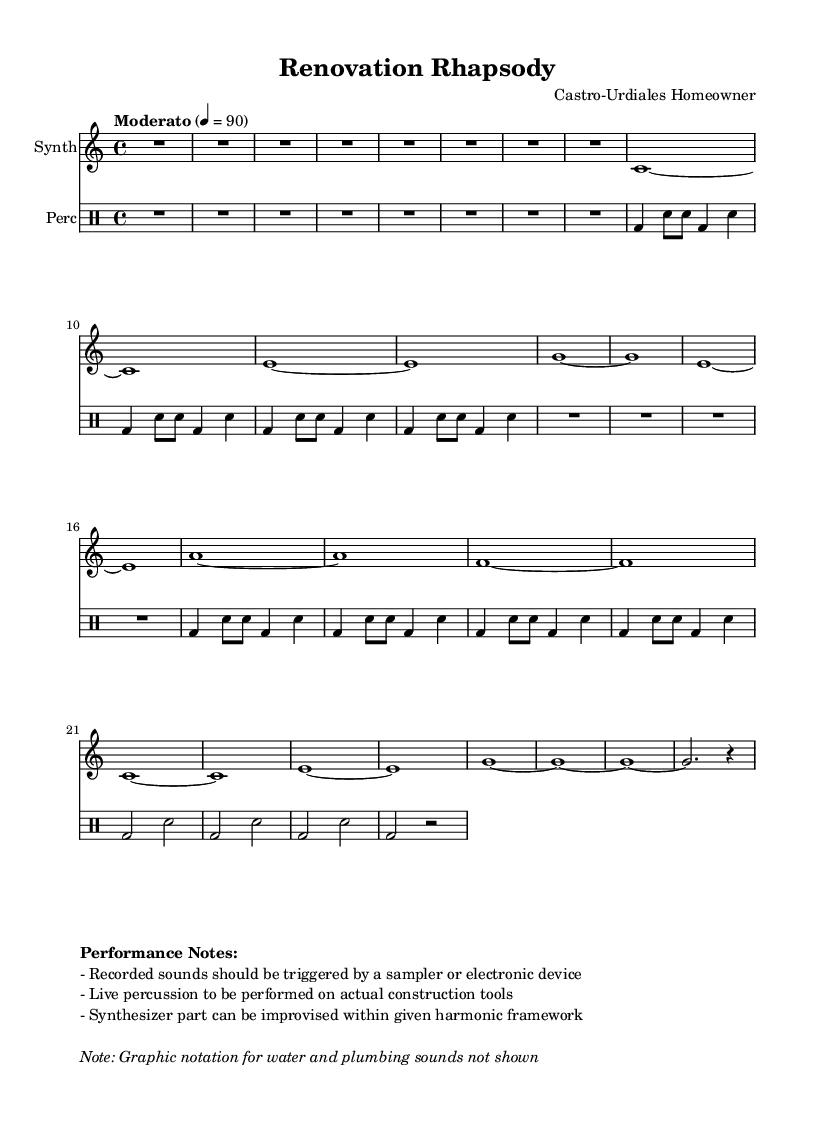What is the key signature of this music? The key signature is indicated at the beginning of the score and shows C major, which has no sharps or flats.
Answer: C major What is the time signature of this music? The time signature is found at the start of the piece and is marked as 4/4, indicating four beats per measure.
Answer: 4/4 What is the tempo marking for this piece? The tempo marking is written above the staff as "Moderato" with a metronome mark of 90 beats per minute, indicating a moderate speed.
Answer: Moderato, 90 How many sections does this piece have? By analyzing the structure of the music, there are three main sections labeled as A, B, and A' followed by a Coda.
Answer: Four What is unique about the percussion part in this piece? The percussion part is specified to be performed on actual construction tools, making it a key element of the musique concrète style.
Answer: Live percussion on construction tools In which way can the synthesizer part be performed? According to the performance notes, the synthesizer part can be improvised within the harmonic framework provided in the score.
Answer: Improvised What is indicated about the recorded sounds? The performance notes mention that recorded sounds should be triggered by a sampler or electronic device, which is a crucial aspect of the piece.
Answer: Triggered by a sampler 